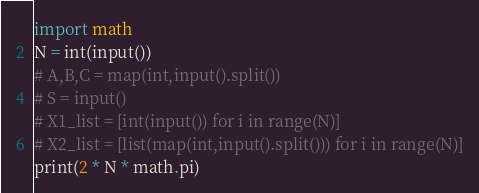<code> <loc_0><loc_0><loc_500><loc_500><_Python_>import math
N = int(input())
# A,B,C = map(int,input().split())
# S = input()
# X1_list = [int(input()) for i in range(N)]
# X2_list = [list(map(int,input().split())) for i in range(N)]
print(2 * N * math.pi)</code> 